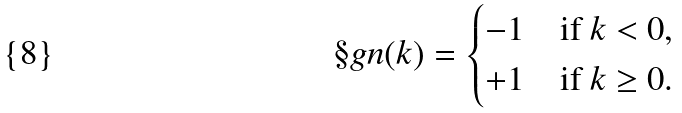<formula> <loc_0><loc_0><loc_500><loc_500>\S g n ( k ) = \begin{cases} - 1 & \text {if $k<0$,} \\ + 1 & \text {if $k\geq 0$.} \end{cases}</formula> 